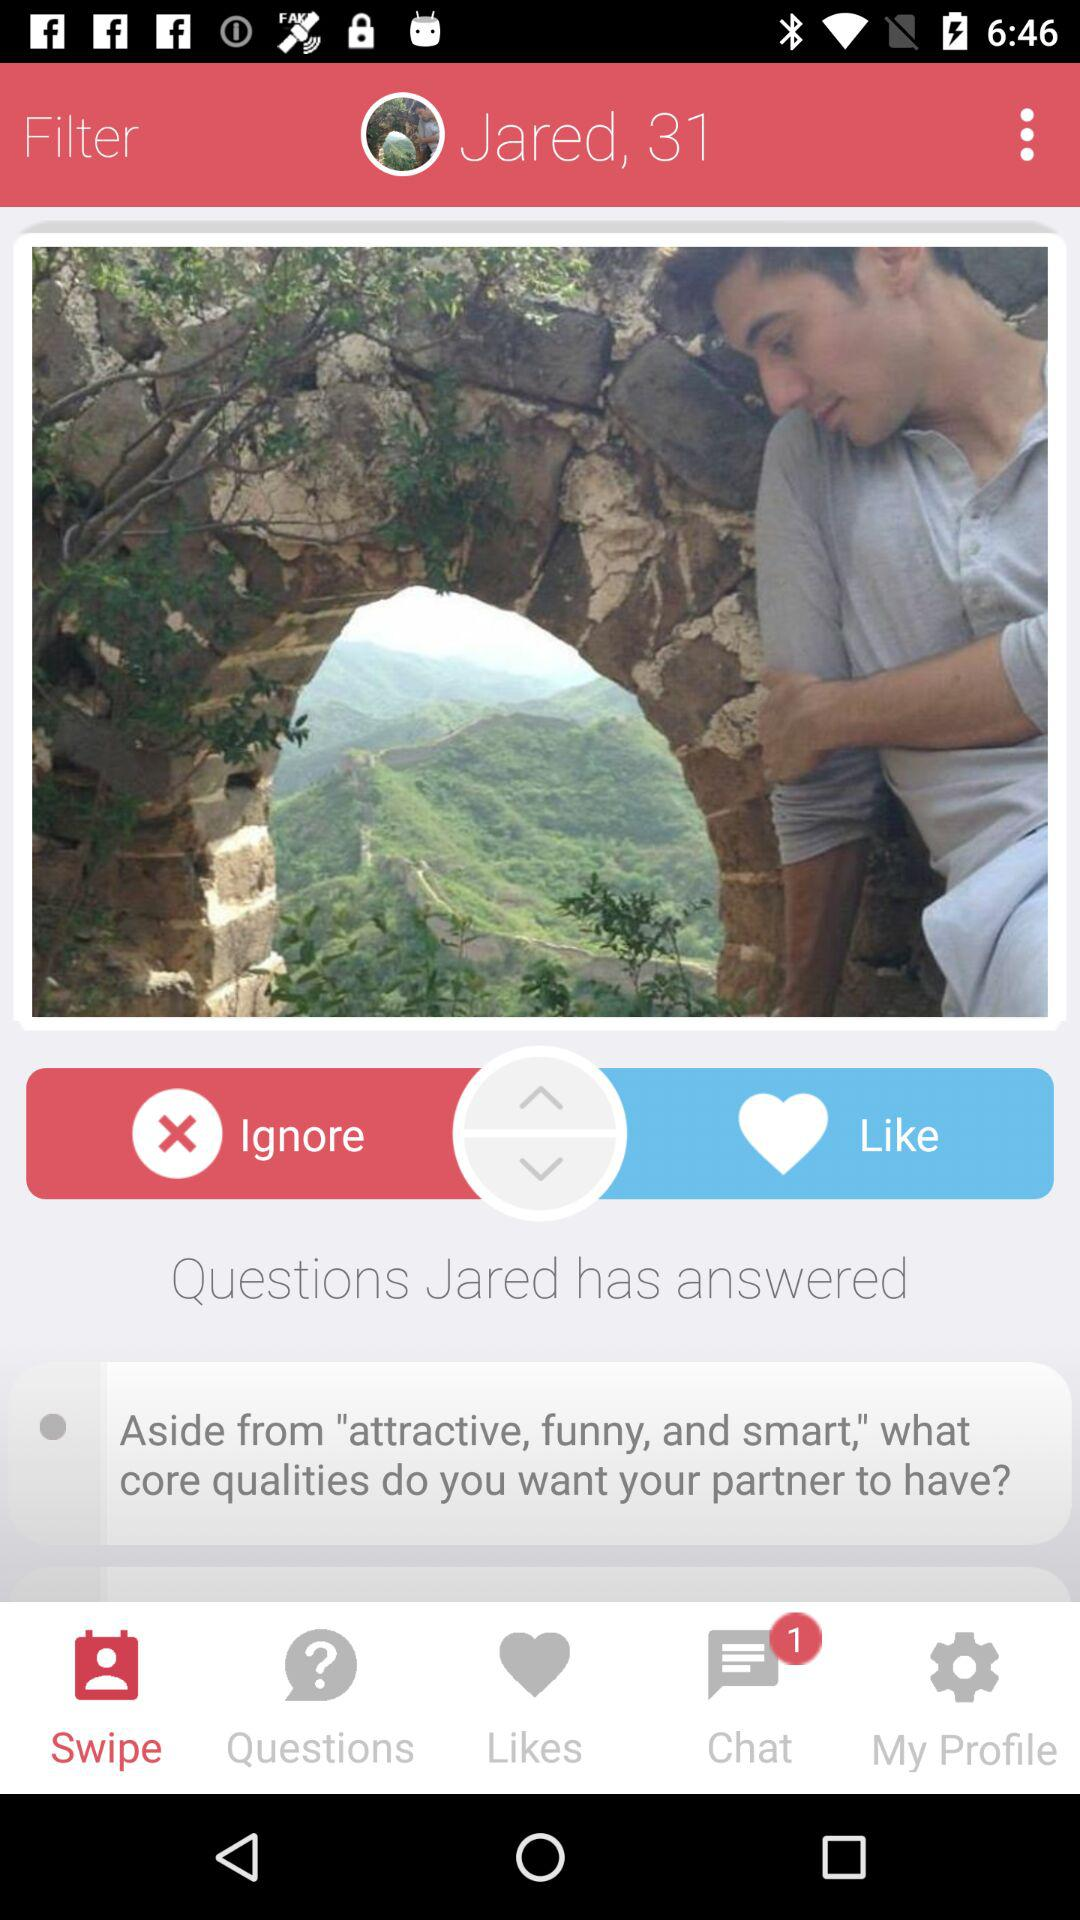How many questions has Jared answered?
Answer the question using a single word or phrase. 1 